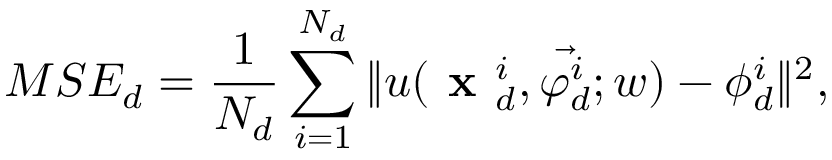<formula> <loc_0><loc_0><loc_500><loc_500>M S E _ { d } = \frac { 1 } { N _ { d } } \sum _ { i = 1 } ^ { N _ { d } } \| u ( x _ { d } ^ { i } , \vec { \varphi _ { d } ^ { i } } ; w ) - \phi _ { d } ^ { i } \| ^ { 2 } ,</formula> 